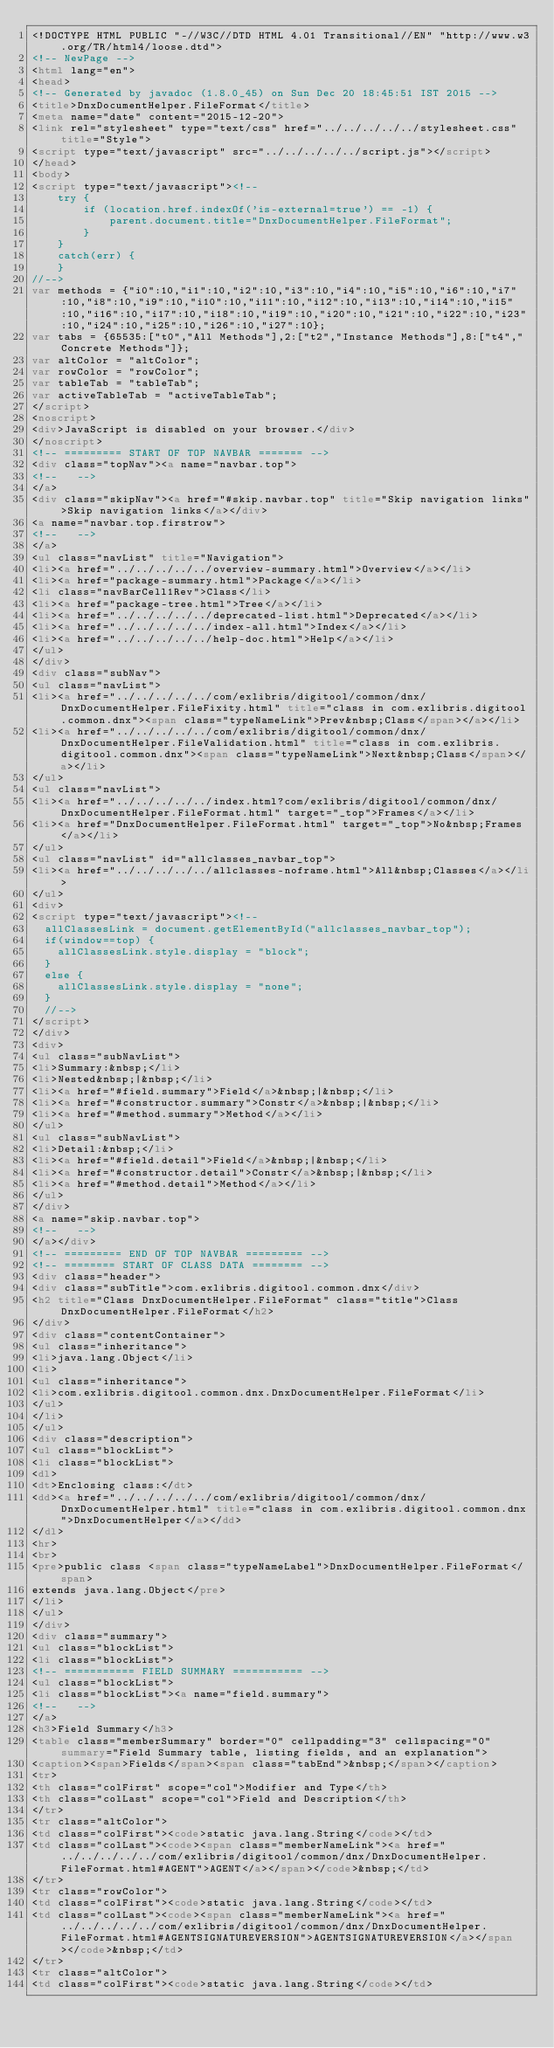<code> <loc_0><loc_0><loc_500><loc_500><_HTML_><!DOCTYPE HTML PUBLIC "-//W3C//DTD HTML 4.01 Transitional//EN" "http://www.w3.org/TR/html4/loose.dtd">
<!-- NewPage -->
<html lang="en">
<head>
<!-- Generated by javadoc (1.8.0_45) on Sun Dec 20 18:45:51 IST 2015 -->
<title>DnxDocumentHelper.FileFormat</title>
<meta name="date" content="2015-12-20">
<link rel="stylesheet" type="text/css" href="../../../../../stylesheet.css" title="Style">
<script type="text/javascript" src="../../../../../script.js"></script>
</head>
<body>
<script type="text/javascript"><!--
    try {
        if (location.href.indexOf('is-external=true') == -1) {
            parent.document.title="DnxDocumentHelper.FileFormat";
        }
    }
    catch(err) {
    }
//-->
var methods = {"i0":10,"i1":10,"i2":10,"i3":10,"i4":10,"i5":10,"i6":10,"i7":10,"i8":10,"i9":10,"i10":10,"i11":10,"i12":10,"i13":10,"i14":10,"i15":10,"i16":10,"i17":10,"i18":10,"i19":10,"i20":10,"i21":10,"i22":10,"i23":10,"i24":10,"i25":10,"i26":10,"i27":10};
var tabs = {65535:["t0","All Methods"],2:["t2","Instance Methods"],8:["t4","Concrete Methods"]};
var altColor = "altColor";
var rowColor = "rowColor";
var tableTab = "tableTab";
var activeTableTab = "activeTableTab";
</script>
<noscript>
<div>JavaScript is disabled on your browser.</div>
</noscript>
<!-- ========= START OF TOP NAVBAR ======= -->
<div class="topNav"><a name="navbar.top">
<!--   -->
</a>
<div class="skipNav"><a href="#skip.navbar.top" title="Skip navigation links">Skip navigation links</a></div>
<a name="navbar.top.firstrow">
<!--   -->
</a>
<ul class="navList" title="Navigation">
<li><a href="../../../../../overview-summary.html">Overview</a></li>
<li><a href="package-summary.html">Package</a></li>
<li class="navBarCell1Rev">Class</li>
<li><a href="package-tree.html">Tree</a></li>
<li><a href="../../../../../deprecated-list.html">Deprecated</a></li>
<li><a href="../../../../../index-all.html">Index</a></li>
<li><a href="../../../../../help-doc.html">Help</a></li>
</ul>
</div>
<div class="subNav">
<ul class="navList">
<li><a href="../../../../../com/exlibris/digitool/common/dnx/DnxDocumentHelper.FileFixity.html" title="class in com.exlibris.digitool.common.dnx"><span class="typeNameLink">Prev&nbsp;Class</span></a></li>
<li><a href="../../../../../com/exlibris/digitool/common/dnx/DnxDocumentHelper.FileValidation.html" title="class in com.exlibris.digitool.common.dnx"><span class="typeNameLink">Next&nbsp;Class</span></a></li>
</ul>
<ul class="navList">
<li><a href="../../../../../index.html?com/exlibris/digitool/common/dnx/DnxDocumentHelper.FileFormat.html" target="_top">Frames</a></li>
<li><a href="DnxDocumentHelper.FileFormat.html" target="_top">No&nbsp;Frames</a></li>
</ul>
<ul class="navList" id="allclasses_navbar_top">
<li><a href="../../../../../allclasses-noframe.html">All&nbsp;Classes</a></li>
</ul>
<div>
<script type="text/javascript"><!--
  allClassesLink = document.getElementById("allclasses_navbar_top");
  if(window==top) {
    allClassesLink.style.display = "block";
  }
  else {
    allClassesLink.style.display = "none";
  }
  //-->
</script>
</div>
<div>
<ul class="subNavList">
<li>Summary:&nbsp;</li>
<li>Nested&nbsp;|&nbsp;</li>
<li><a href="#field.summary">Field</a>&nbsp;|&nbsp;</li>
<li><a href="#constructor.summary">Constr</a>&nbsp;|&nbsp;</li>
<li><a href="#method.summary">Method</a></li>
</ul>
<ul class="subNavList">
<li>Detail:&nbsp;</li>
<li><a href="#field.detail">Field</a>&nbsp;|&nbsp;</li>
<li><a href="#constructor.detail">Constr</a>&nbsp;|&nbsp;</li>
<li><a href="#method.detail">Method</a></li>
</ul>
</div>
<a name="skip.navbar.top">
<!--   -->
</a></div>
<!-- ========= END OF TOP NAVBAR ========= -->
<!-- ======== START OF CLASS DATA ======== -->
<div class="header">
<div class="subTitle">com.exlibris.digitool.common.dnx</div>
<h2 title="Class DnxDocumentHelper.FileFormat" class="title">Class DnxDocumentHelper.FileFormat</h2>
</div>
<div class="contentContainer">
<ul class="inheritance">
<li>java.lang.Object</li>
<li>
<ul class="inheritance">
<li>com.exlibris.digitool.common.dnx.DnxDocumentHelper.FileFormat</li>
</ul>
</li>
</ul>
<div class="description">
<ul class="blockList">
<li class="blockList">
<dl>
<dt>Enclosing class:</dt>
<dd><a href="../../../../../com/exlibris/digitool/common/dnx/DnxDocumentHelper.html" title="class in com.exlibris.digitool.common.dnx">DnxDocumentHelper</a></dd>
</dl>
<hr>
<br>
<pre>public class <span class="typeNameLabel">DnxDocumentHelper.FileFormat</span>
extends java.lang.Object</pre>
</li>
</ul>
</div>
<div class="summary">
<ul class="blockList">
<li class="blockList">
<!-- =========== FIELD SUMMARY =========== -->
<ul class="blockList">
<li class="blockList"><a name="field.summary">
<!--   -->
</a>
<h3>Field Summary</h3>
<table class="memberSummary" border="0" cellpadding="3" cellspacing="0" summary="Field Summary table, listing fields, and an explanation">
<caption><span>Fields</span><span class="tabEnd">&nbsp;</span></caption>
<tr>
<th class="colFirst" scope="col">Modifier and Type</th>
<th class="colLast" scope="col">Field and Description</th>
</tr>
<tr class="altColor">
<td class="colFirst"><code>static java.lang.String</code></td>
<td class="colLast"><code><span class="memberNameLink"><a href="../../../../../com/exlibris/digitool/common/dnx/DnxDocumentHelper.FileFormat.html#AGENT">AGENT</a></span></code>&nbsp;</td>
</tr>
<tr class="rowColor">
<td class="colFirst"><code>static java.lang.String</code></td>
<td class="colLast"><code><span class="memberNameLink"><a href="../../../../../com/exlibris/digitool/common/dnx/DnxDocumentHelper.FileFormat.html#AGENTSIGNATUREVERSION">AGENTSIGNATUREVERSION</a></span></code>&nbsp;</td>
</tr>
<tr class="altColor">
<td class="colFirst"><code>static java.lang.String</code></td></code> 